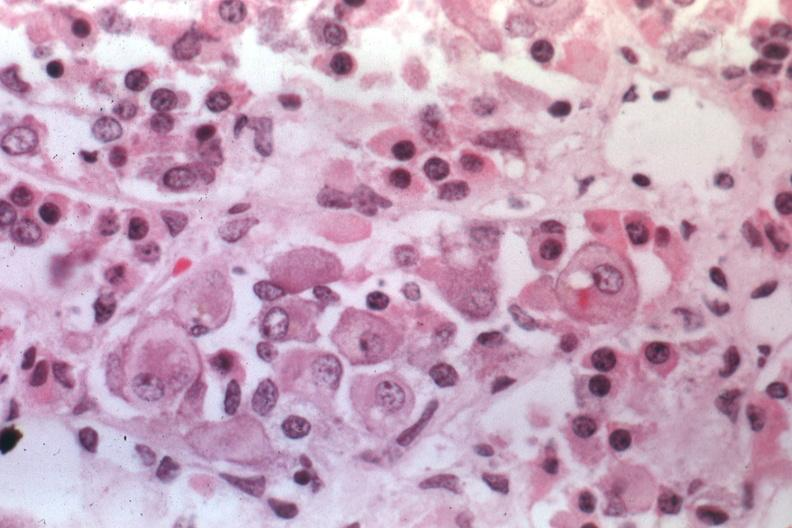where is this part in the figure?
Answer the question using a single word or phrase. Endocrine system 